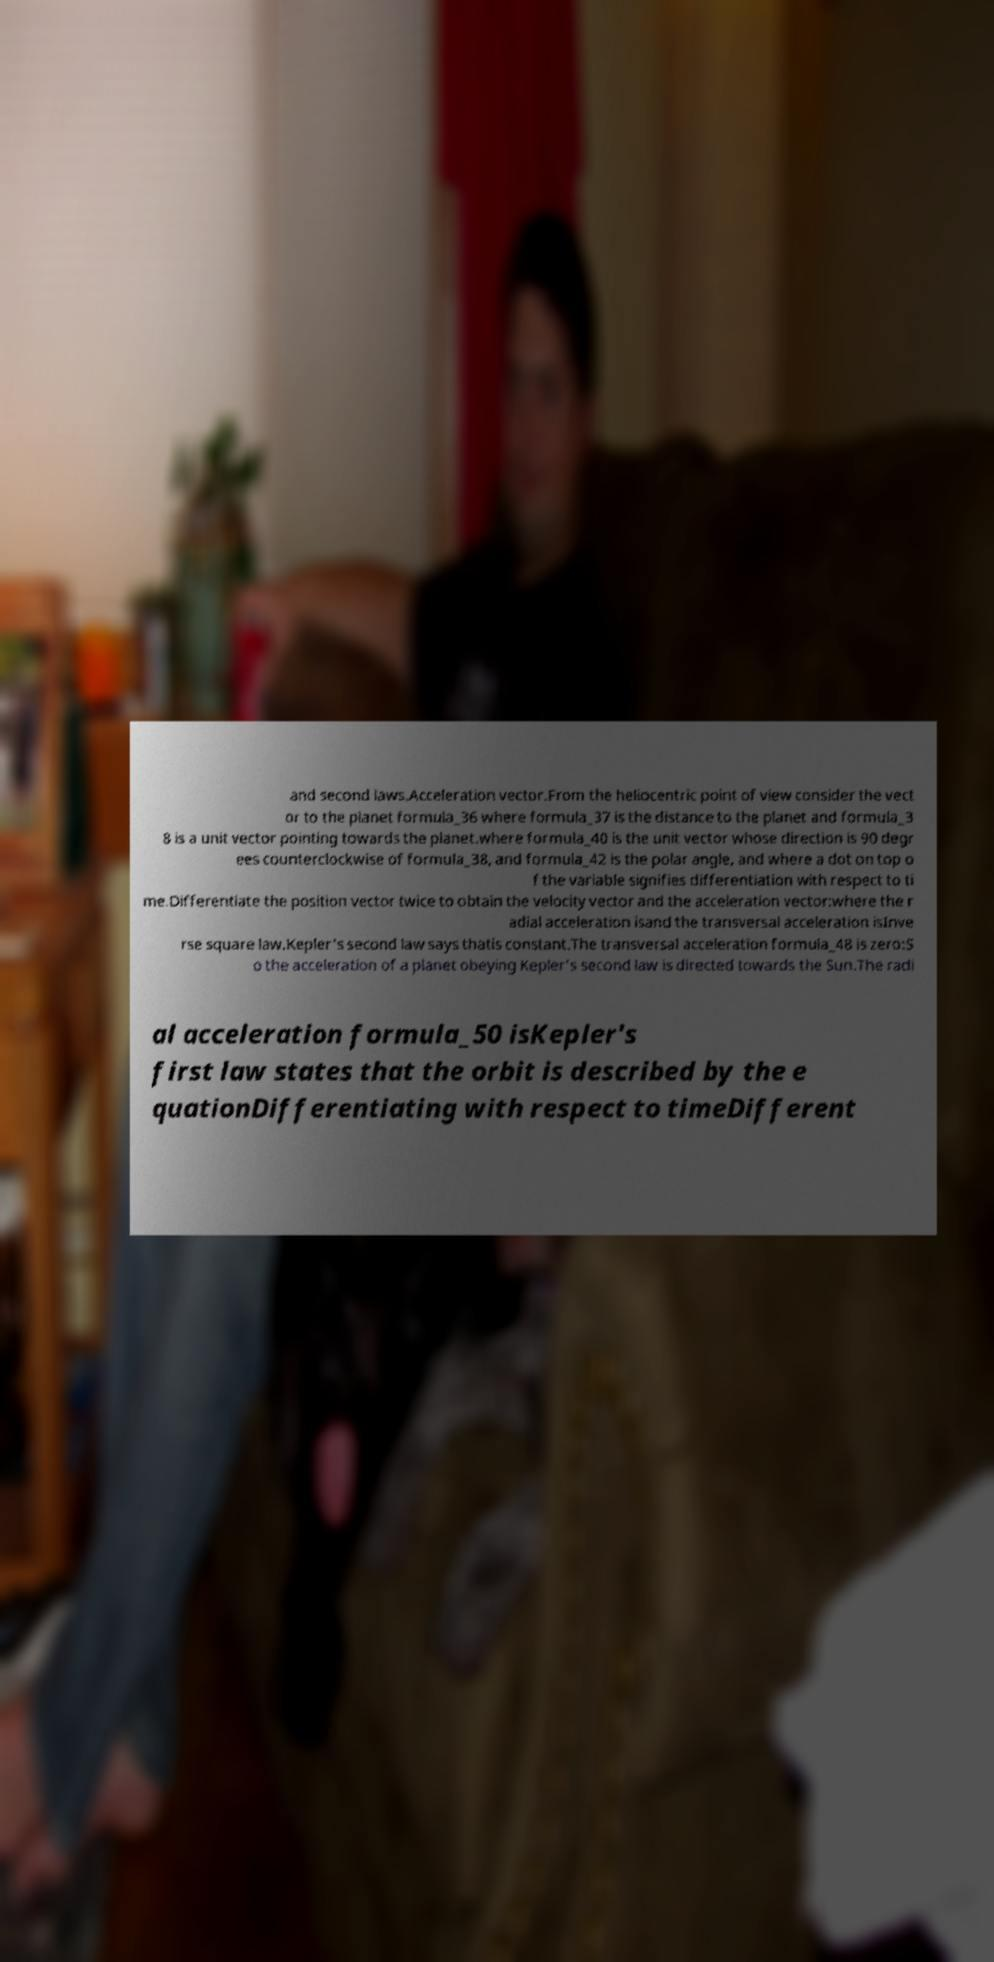Could you extract and type out the text from this image? and second laws.Acceleration vector.From the heliocentric point of view consider the vect or to the planet formula_36 where formula_37 is the distance to the planet and formula_3 8 is a unit vector pointing towards the planet.where formula_40 is the unit vector whose direction is 90 degr ees counterclockwise of formula_38, and formula_42 is the polar angle, and where a dot on top o f the variable signifies differentiation with respect to ti me.Differentiate the position vector twice to obtain the velocity vector and the acceleration vector:where the r adial acceleration isand the transversal acceleration isInve rse square law.Kepler's second law says thatis constant.The transversal acceleration formula_48 is zero:S o the acceleration of a planet obeying Kepler's second law is directed towards the Sun.The radi al acceleration formula_50 isKepler's first law states that the orbit is described by the e quationDifferentiating with respect to timeDifferent 